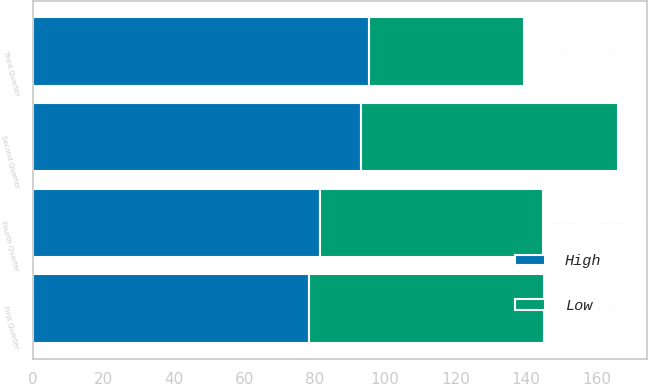Convert chart. <chart><loc_0><loc_0><loc_500><loc_500><stacked_bar_chart><ecel><fcel>First Quarter<fcel>Second Quarter<fcel>Third Quarter<fcel>Fourth Quarter<nl><fcel>High<fcel>78.44<fcel>93.09<fcel>95.49<fcel>81.39<nl><fcel>Low<fcel>66.63<fcel>73.02<fcel>43.91<fcel>63.32<nl></chart> 